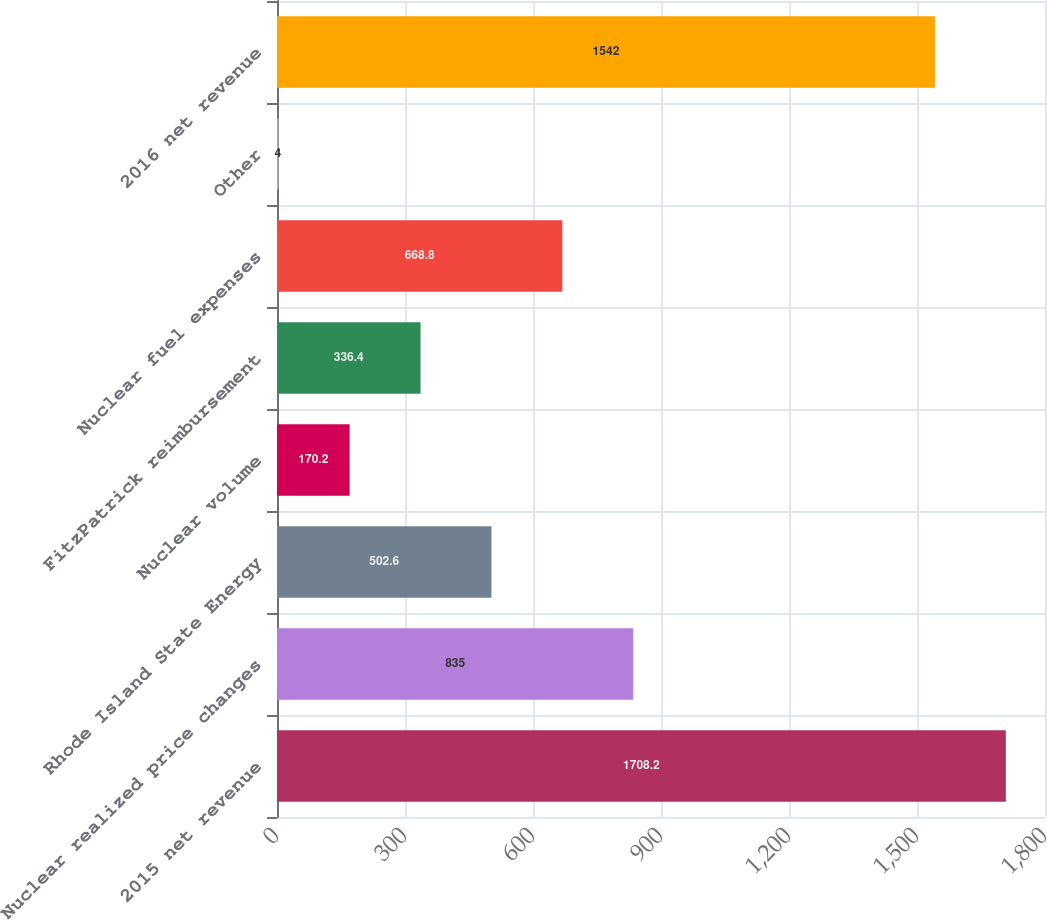<chart> <loc_0><loc_0><loc_500><loc_500><bar_chart><fcel>2015 net revenue<fcel>Nuclear realized price changes<fcel>Rhode Island State Energy<fcel>Nuclear volume<fcel>FitzPatrick reimbursement<fcel>Nuclear fuel expenses<fcel>Other<fcel>2016 net revenue<nl><fcel>1708.2<fcel>835<fcel>502.6<fcel>170.2<fcel>336.4<fcel>668.8<fcel>4<fcel>1542<nl></chart> 